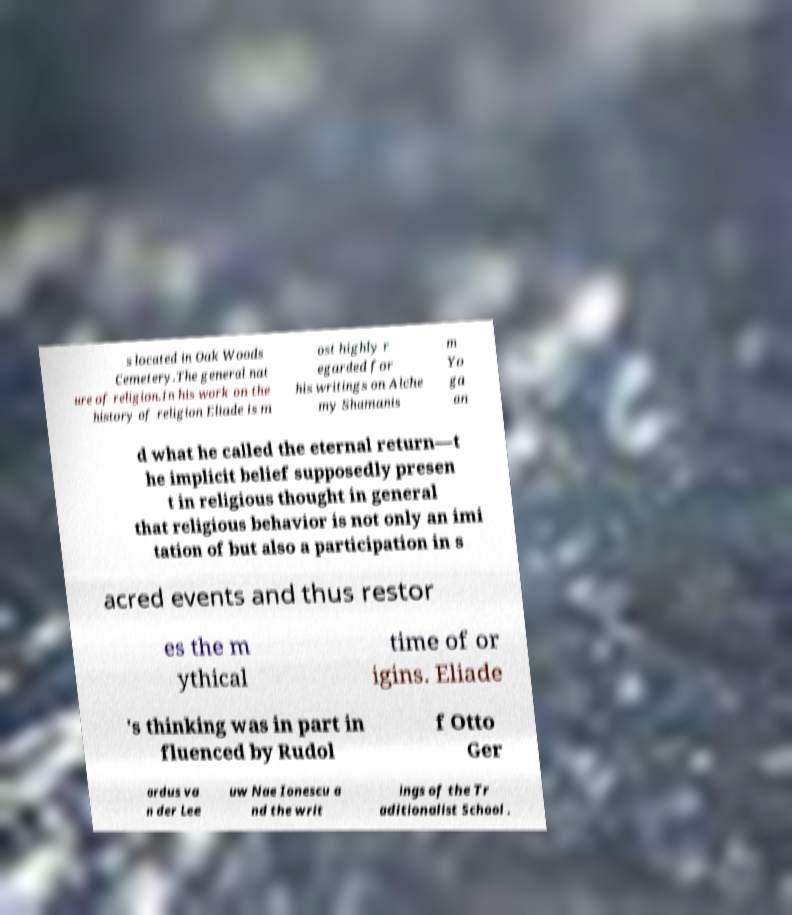There's text embedded in this image that I need extracted. Can you transcribe it verbatim? s located in Oak Woods Cemetery.The general nat ure of religion.In his work on the history of religion Eliade is m ost highly r egarded for his writings on Alche my Shamanis m Yo ga an d what he called the eternal return—t he implicit belief supposedly presen t in religious thought in general that religious behavior is not only an imi tation of but also a participation in s acred events and thus restor es the m ythical time of or igins. Eliade 's thinking was in part in fluenced by Rudol f Otto Ger ardus va n der Lee uw Nae Ionescu a nd the writ ings of the Tr aditionalist School . 